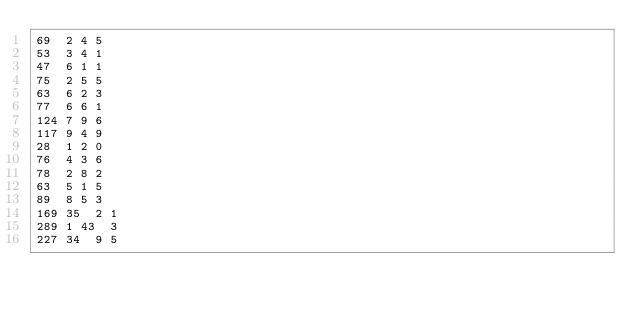<code> <loc_0><loc_0><loc_500><loc_500><_SQL_>69	2	4	5
53	3	4	1
47	6	1	1
75	2	5	5
63	6	2	3
77	6	6	1
124	7	9	6
117	9	4	9
28	1	2	0
76	4	3	6
78	2	8	2
63	5	1	5
89	8	5	3
169	35	2	1
289	1	43	3
227	34	9	5</code> 